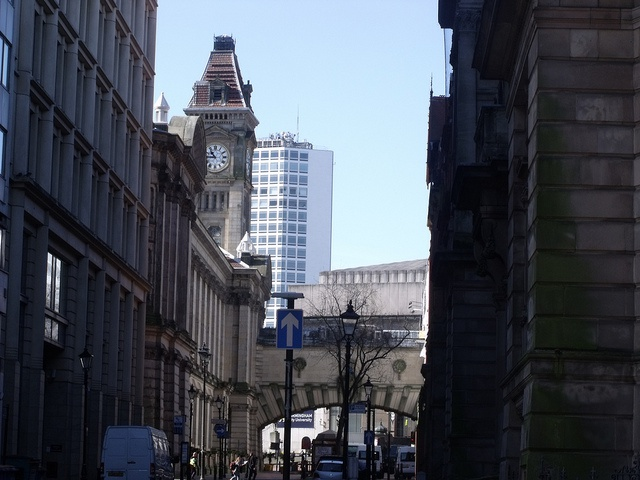Describe the objects in this image and their specific colors. I can see truck in blue, navy, black, gray, and darkgray tones, car in blue, black, and gray tones, clock in blue, darkgray, and gray tones, car in blue, black, navy, darkblue, and gray tones, and car in blue, black, and gray tones in this image. 